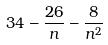<formula> <loc_0><loc_0><loc_500><loc_500>3 4 - \frac { 2 6 } { n } - \frac { 8 } { n ^ { 2 } }</formula> 